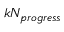<formula> <loc_0><loc_0><loc_500><loc_500>k N _ { p r o g r e s s }</formula> 